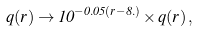Convert formula to latex. <formula><loc_0><loc_0><loc_500><loc_500>q ( r ) \rightarrow 1 0 ^ { - 0 . 0 5 ( r - 8 . ) } \times q ( r ) \, ,</formula> 